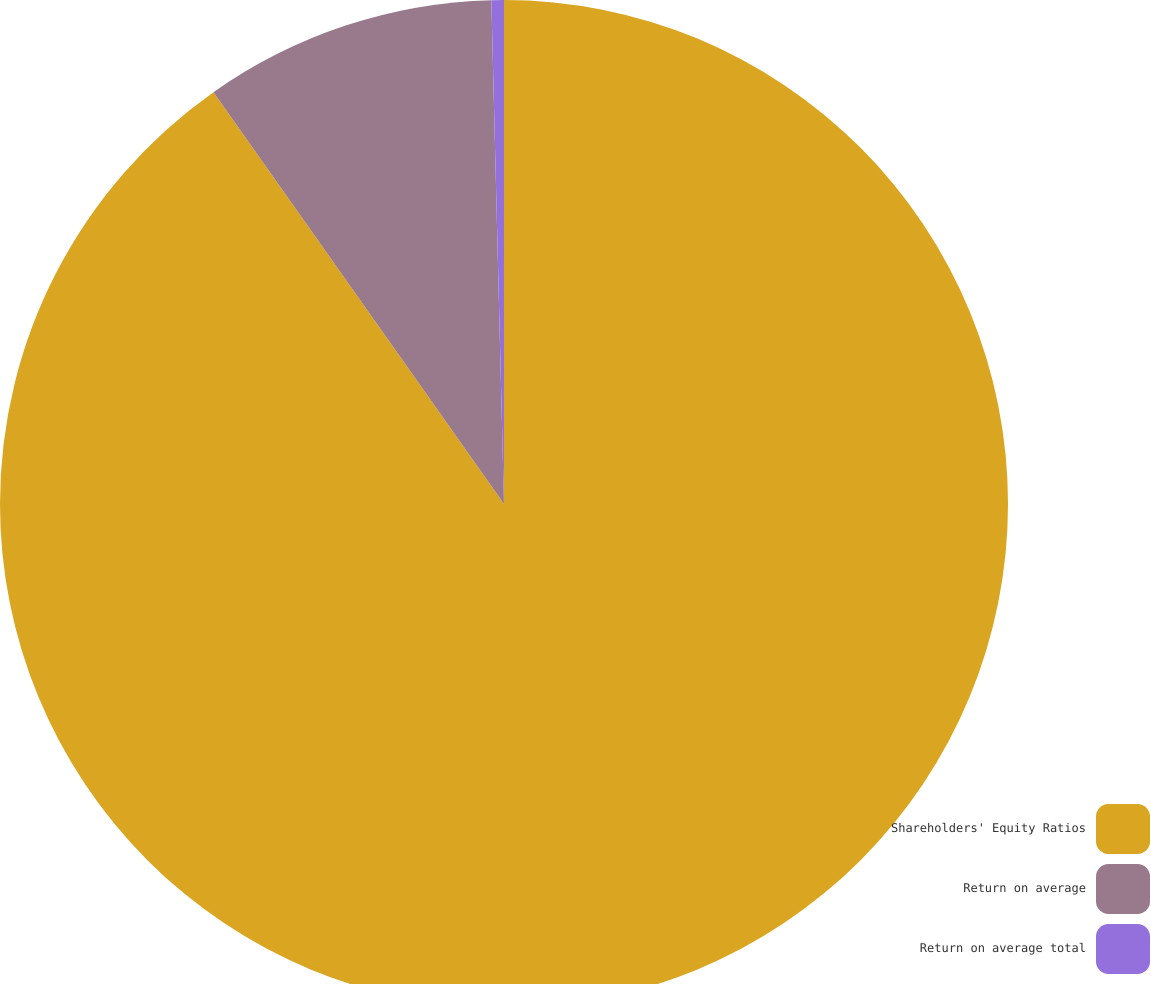<chart> <loc_0><loc_0><loc_500><loc_500><pie_chart><fcel>Shareholders' Equity Ratios<fcel>Return on average<fcel>Return on average total<nl><fcel>90.23%<fcel>9.38%<fcel>0.4%<nl></chart> 